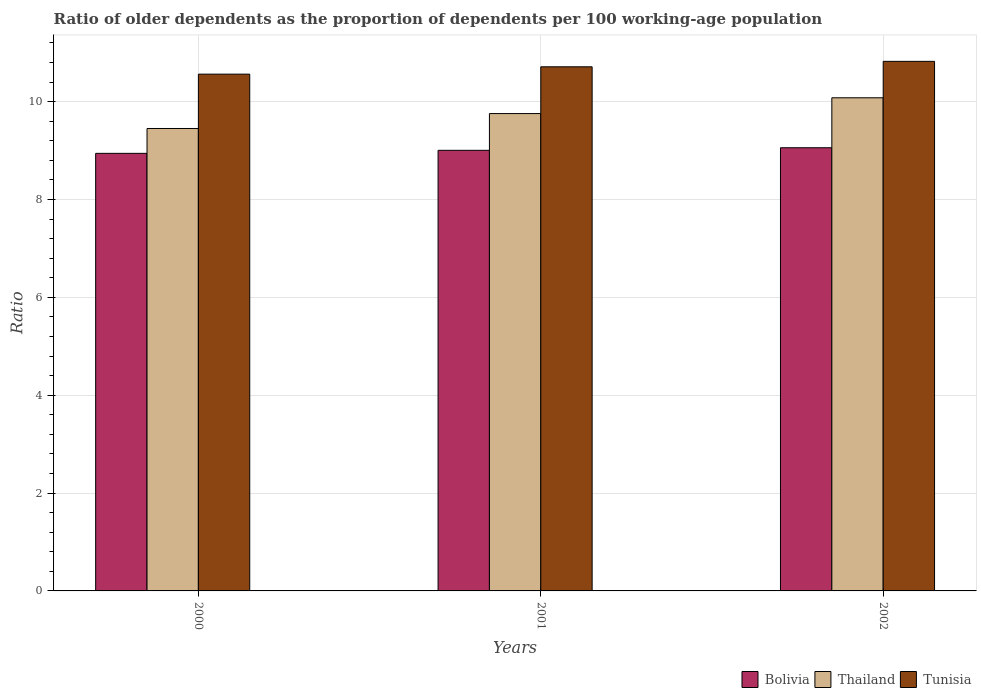How many groups of bars are there?
Give a very brief answer. 3. Are the number of bars per tick equal to the number of legend labels?
Offer a terse response. Yes. How many bars are there on the 2nd tick from the left?
Offer a terse response. 3. How many bars are there on the 2nd tick from the right?
Offer a terse response. 3. What is the label of the 2nd group of bars from the left?
Make the answer very short. 2001. In how many cases, is the number of bars for a given year not equal to the number of legend labels?
Your answer should be compact. 0. What is the age dependency ratio(old) in Thailand in 2002?
Your response must be concise. 10.08. Across all years, what is the maximum age dependency ratio(old) in Thailand?
Provide a short and direct response. 10.08. Across all years, what is the minimum age dependency ratio(old) in Thailand?
Ensure brevity in your answer.  9.45. What is the total age dependency ratio(old) in Thailand in the graph?
Offer a terse response. 29.29. What is the difference between the age dependency ratio(old) in Bolivia in 2000 and that in 2002?
Provide a short and direct response. -0.11. What is the difference between the age dependency ratio(old) in Thailand in 2000 and the age dependency ratio(old) in Bolivia in 2001?
Give a very brief answer. 0.45. What is the average age dependency ratio(old) in Bolivia per year?
Provide a short and direct response. 9. In the year 2001, what is the difference between the age dependency ratio(old) in Bolivia and age dependency ratio(old) in Thailand?
Provide a short and direct response. -0.75. In how many years, is the age dependency ratio(old) in Thailand greater than 9.2?
Keep it short and to the point. 3. What is the ratio of the age dependency ratio(old) in Thailand in 2001 to that in 2002?
Offer a terse response. 0.97. Is the age dependency ratio(old) in Bolivia in 2001 less than that in 2002?
Your response must be concise. Yes. What is the difference between the highest and the second highest age dependency ratio(old) in Thailand?
Provide a succinct answer. 0.32. What is the difference between the highest and the lowest age dependency ratio(old) in Tunisia?
Make the answer very short. 0.26. In how many years, is the age dependency ratio(old) in Bolivia greater than the average age dependency ratio(old) in Bolivia taken over all years?
Keep it short and to the point. 2. What does the 2nd bar from the left in 2000 represents?
Your response must be concise. Thailand. Is it the case that in every year, the sum of the age dependency ratio(old) in Thailand and age dependency ratio(old) in Bolivia is greater than the age dependency ratio(old) in Tunisia?
Make the answer very short. Yes. How many years are there in the graph?
Your response must be concise. 3. What is the difference between two consecutive major ticks on the Y-axis?
Your answer should be compact. 2. Are the values on the major ticks of Y-axis written in scientific E-notation?
Your answer should be compact. No. Where does the legend appear in the graph?
Make the answer very short. Bottom right. What is the title of the graph?
Offer a terse response. Ratio of older dependents as the proportion of dependents per 100 working-age population. What is the label or title of the X-axis?
Provide a succinct answer. Years. What is the label or title of the Y-axis?
Provide a succinct answer. Ratio. What is the Ratio of Bolivia in 2000?
Provide a succinct answer. 8.94. What is the Ratio in Thailand in 2000?
Your answer should be very brief. 9.45. What is the Ratio in Tunisia in 2000?
Ensure brevity in your answer.  10.56. What is the Ratio of Bolivia in 2001?
Ensure brevity in your answer.  9.01. What is the Ratio of Thailand in 2001?
Your answer should be very brief. 9.76. What is the Ratio in Tunisia in 2001?
Provide a succinct answer. 10.71. What is the Ratio of Bolivia in 2002?
Offer a terse response. 9.06. What is the Ratio of Thailand in 2002?
Give a very brief answer. 10.08. What is the Ratio in Tunisia in 2002?
Your response must be concise. 10.82. Across all years, what is the maximum Ratio of Bolivia?
Your answer should be compact. 9.06. Across all years, what is the maximum Ratio of Thailand?
Offer a very short reply. 10.08. Across all years, what is the maximum Ratio in Tunisia?
Make the answer very short. 10.82. Across all years, what is the minimum Ratio in Bolivia?
Make the answer very short. 8.94. Across all years, what is the minimum Ratio of Thailand?
Give a very brief answer. 9.45. Across all years, what is the minimum Ratio in Tunisia?
Ensure brevity in your answer.  10.56. What is the total Ratio of Bolivia in the graph?
Keep it short and to the point. 27.01. What is the total Ratio of Thailand in the graph?
Keep it short and to the point. 29.29. What is the total Ratio in Tunisia in the graph?
Offer a terse response. 32.1. What is the difference between the Ratio in Bolivia in 2000 and that in 2001?
Keep it short and to the point. -0.06. What is the difference between the Ratio of Thailand in 2000 and that in 2001?
Your answer should be compact. -0.3. What is the difference between the Ratio in Tunisia in 2000 and that in 2001?
Provide a short and direct response. -0.15. What is the difference between the Ratio of Bolivia in 2000 and that in 2002?
Ensure brevity in your answer.  -0.11. What is the difference between the Ratio of Thailand in 2000 and that in 2002?
Provide a short and direct response. -0.63. What is the difference between the Ratio in Tunisia in 2000 and that in 2002?
Your answer should be compact. -0.26. What is the difference between the Ratio of Bolivia in 2001 and that in 2002?
Your response must be concise. -0.05. What is the difference between the Ratio of Thailand in 2001 and that in 2002?
Provide a short and direct response. -0.32. What is the difference between the Ratio of Tunisia in 2001 and that in 2002?
Make the answer very short. -0.11. What is the difference between the Ratio in Bolivia in 2000 and the Ratio in Thailand in 2001?
Make the answer very short. -0.81. What is the difference between the Ratio in Bolivia in 2000 and the Ratio in Tunisia in 2001?
Provide a short and direct response. -1.77. What is the difference between the Ratio of Thailand in 2000 and the Ratio of Tunisia in 2001?
Offer a very short reply. -1.26. What is the difference between the Ratio in Bolivia in 2000 and the Ratio in Thailand in 2002?
Your answer should be very brief. -1.14. What is the difference between the Ratio of Bolivia in 2000 and the Ratio of Tunisia in 2002?
Offer a very short reply. -1.88. What is the difference between the Ratio of Thailand in 2000 and the Ratio of Tunisia in 2002?
Your answer should be very brief. -1.37. What is the difference between the Ratio in Bolivia in 2001 and the Ratio in Thailand in 2002?
Your answer should be very brief. -1.07. What is the difference between the Ratio in Bolivia in 2001 and the Ratio in Tunisia in 2002?
Give a very brief answer. -1.82. What is the difference between the Ratio of Thailand in 2001 and the Ratio of Tunisia in 2002?
Keep it short and to the point. -1.07. What is the average Ratio of Bolivia per year?
Offer a terse response. 9. What is the average Ratio in Thailand per year?
Provide a short and direct response. 9.76. What is the average Ratio in Tunisia per year?
Your answer should be very brief. 10.7. In the year 2000, what is the difference between the Ratio in Bolivia and Ratio in Thailand?
Offer a terse response. -0.51. In the year 2000, what is the difference between the Ratio of Bolivia and Ratio of Tunisia?
Give a very brief answer. -1.62. In the year 2000, what is the difference between the Ratio of Thailand and Ratio of Tunisia?
Your answer should be compact. -1.11. In the year 2001, what is the difference between the Ratio in Bolivia and Ratio in Thailand?
Ensure brevity in your answer.  -0.75. In the year 2001, what is the difference between the Ratio in Bolivia and Ratio in Tunisia?
Give a very brief answer. -1.71. In the year 2001, what is the difference between the Ratio of Thailand and Ratio of Tunisia?
Ensure brevity in your answer.  -0.96. In the year 2002, what is the difference between the Ratio of Bolivia and Ratio of Thailand?
Keep it short and to the point. -1.02. In the year 2002, what is the difference between the Ratio in Bolivia and Ratio in Tunisia?
Offer a terse response. -1.77. In the year 2002, what is the difference between the Ratio of Thailand and Ratio of Tunisia?
Your response must be concise. -0.74. What is the ratio of the Ratio of Bolivia in 2000 to that in 2001?
Provide a short and direct response. 0.99. What is the ratio of the Ratio of Thailand in 2000 to that in 2001?
Make the answer very short. 0.97. What is the ratio of the Ratio of Tunisia in 2000 to that in 2001?
Your answer should be compact. 0.99. What is the ratio of the Ratio in Bolivia in 2000 to that in 2002?
Provide a short and direct response. 0.99. What is the ratio of the Ratio of Thailand in 2000 to that in 2002?
Provide a short and direct response. 0.94. What is the ratio of the Ratio of Tunisia in 2000 to that in 2002?
Your response must be concise. 0.98. What is the difference between the highest and the second highest Ratio in Bolivia?
Your answer should be very brief. 0.05. What is the difference between the highest and the second highest Ratio of Thailand?
Provide a succinct answer. 0.32. What is the difference between the highest and the second highest Ratio in Tunisia?
Your answer should be very brief. 0.11. What is the difference between the highest and the lowest Ratio in Bolivia?
Keep it short and to the point. 0.11. What is the difference between the highest and the lowest Ratio of Thailand?
Give a very brief answer. 0.63. What is the difference between the highest and the lowest Ratio in Tunisia?
Provide a short and direct response. 0.26. 